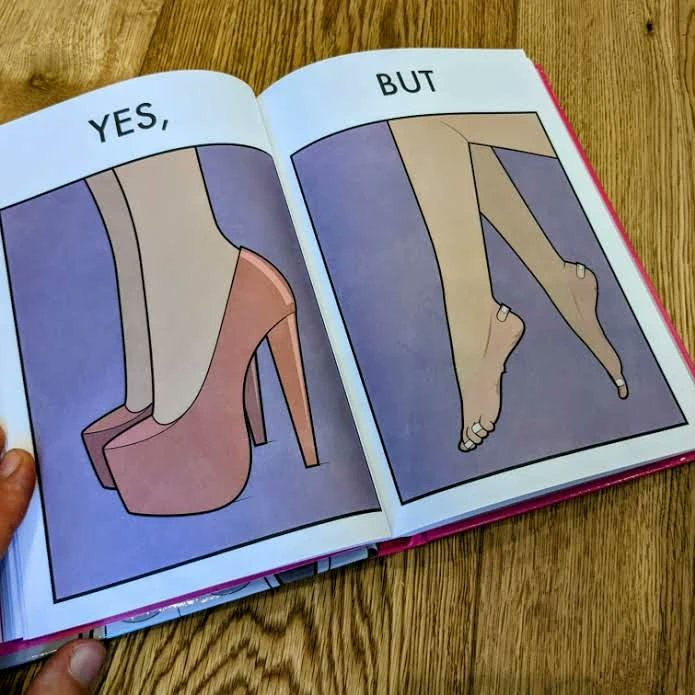What is shown in this image? The images are funny since they show how the prettiest footwears like high heels, end up causing a lot of physical discomfort to the user, all in the name fashion 